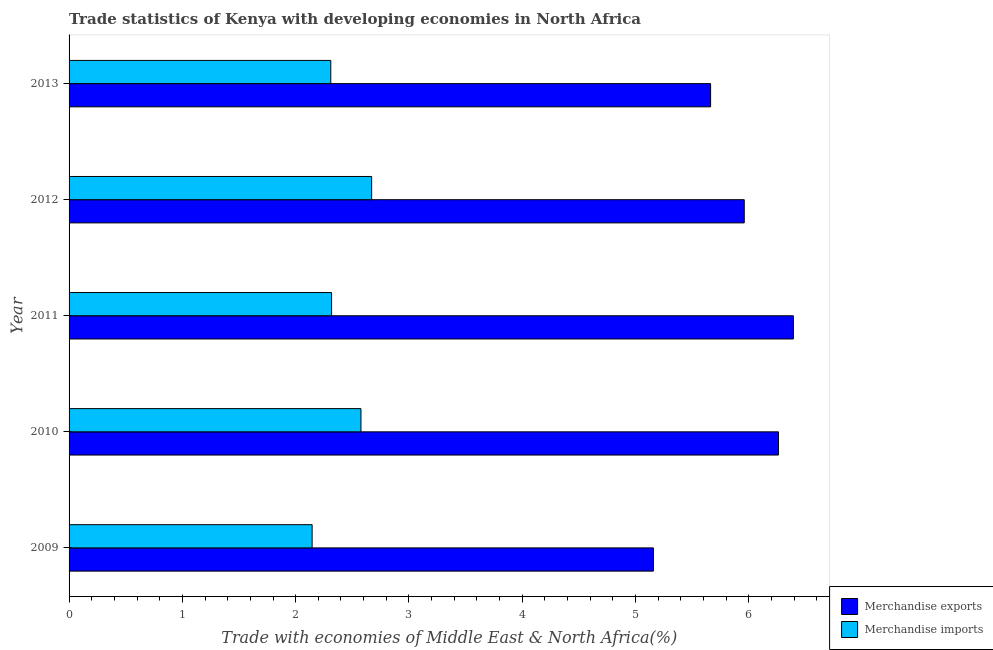How many different coloured bars are there?
Your answer should be compact. 2. Are the number of bars on each tick of the Y-axis equal?
Offer a very short reply. Yes. How many bars are there on the 3rd tick from the top?
Your response must be concise. 2. How many bars are there on the 2nd tick from the bottom?
Your answer should be compact. 2. In how many cases, is the number of bars for a given year not equal to the number of legend labels?
Offer a very short reply. 0. What is the merchandise exports in 2009?
Offer a terse response. 5.16. Across all years, what is the maximum merchandise imports?
Offer a terse response. 2.67. Across all years, what is the minimum merchandise imports?
Provide a succinct answer. 2.15. In which year was the merchandise imports minimum?
Your answer should be compact. 2009. What is the total merchandise exports in the graph?
Your response must be concise. 29.43. What is the difference between the merchandise exports in 2009 and that in 2011?
Your answer should be compact. -1.24. What is the difference between the merchandise imports in 2009 and the merchandise exports in 2010?
Provide a succinct answer. -4.12. What is the average merchandise exports per year?
Give a very brief answer. 5.89. In the year 2009, what is the difference between the merchandise exports and merchandise imports?
Give a very brief answer. 3.01. In how many years, is the merchandise imports greater than 6.2 %?
Your answer should be compact. 0. What is the ratio of the merchandise imports in 2009 to that in 2010?
Make the answer very short. 0.83. Is the merchandise imports in 2009 less than that in 2010?
Offer a very short reply. Yes. Is the difference between the merchandise exports in 2011 and 2012 greater than the difference between the merchandise imports in 2011 and 2012?
Your response must be concise. Yes. What is the difference between the highest and the second highest merchandise exports?
Ensure brevity in your answer.  0.13. What is the difference between the highest and the lowest merchandise imports?
Offer a very short reply. 0.53. In how many years, is the merchandise imports greater than the average merchandise imports taken over all years?
Your answer should be compact. 2. What does the 1st bar from the bottom in 2012 represents?
Your answer should be very brief. Merchandise exports. How many bars are there?
Provide a succinct answer. 10. Are all the bars in the graph horizontal?
Your answer should be very brief. Yes. How many years are there in the graph?
Your answer should be compact. 5. What is the difference between two consecutive major ticks on the X-axis?
Keep it short and to the point. 1. Are the values on the major ticks of X-axis written in scientific E-notation?
Offer a very short reply. No. Does the graph contain any zero values?
Offer a very short reply. No. Where does the legend appear in the graph?
Your response must be concise. Bottom right. How many legend labels are there?
Your response must be concise. 2. What is the title of the graph?
Offer a terse response. Trade statistics of Kenya with developing economies in North Africa. What is the label or title of the X-axis?
Provide a succinct answer. Trade with economies of Middle East & North Africa(%). What is the label or title of the Y-axis?
Your answer should be compact. Year. What is the Trade with economies of Middle East & North Africa(%) in Merchandise exports in 2009?
Ensure brevity in your answer.  5.16. What is the Trade with economies of Middle East & North Africa(%) of Merchandise imports in 2009?
Your answer should be very brief. 2.15. What is the Trade with economies of Middle East & North Africa(%) in Merchandise exports in 2010?
Ensure brevity in your answer.  6.26. What is the Trade with economies of Middle East & North Africa(%) of Merchandise imports in 2010?
Offer a terse response. 2.58. What is the Trade with economies of Middle East & North Africa(%) in Merchandise exports in 2011?
Your response must be concise. 6.39. What is the Trade with economies of Middle East & North Africa(%) in Merchandise imports in 2011?
Offer a very short reply. 2.32. What is the Trade with economies of Middle East & North Africa(%) in Merchandise exports in 2012?
Make the answer very short. 5.96. What is the Trade with economies of Middle East & North Africa(%) of Merchandise imports in 2012?
Your response must be concise. 2.67. What is the Trade with economies of Middle East & North Africa(%) in Merchandise exports in 2013?
Ensure brevity in your answer.  5.66. What is the Trade with economies of Middle East & North Africa(%) in Merchandise imports in 2013?
Your answer should be very brief. 2.31. Across all years, what is the maximum Trade with economies of Middle East & North Africa(%) of Merchandise exports?
Provide a succinct answer. 6.39. Across all years, what is the maximum Trade with economies of Middle East & North Africa(%) of Merchandise imports?
Your answer should be compact. 2.67. Across all years, what is the minimum Trade with economies of Middle East & North Africa(%) of Merchandise exports?
Provide a succinct answer. 5.16. Across all years, what is the minimum Trade with economies of Middle East & North Africa(%) of Merchandise imports?
Your answer should be very brief. 2.15. What is the total Trade with economies of Middle East & North Africa(%) of Merchandise exports in the graph?
Keep it short and to the point. 29.43. What is the total Trade with economies of Middle East & North Africa(%) of Merchandise imports in the graph?
Your response must be concise. 12.02. What is the difference between the Trade with economies of Middle East & North Africa(%) in Merchandise exports in 2009 and that in 2010?
Make the answer very short. -1.1. What is the difference between the Trade with economies of Middle East & North Africa(%) in Merchandise imports in 2009 and that in 2010?
Offer a terse response. -0.43. What is the difference between the Trade with economies of Middle East & North Africa(%) of Merchandise exports in 2009 and that in 2011?
Provide a succinct answer. -1.24. What is the difference between the Trade with economies of Middle East & North Africa(%) in Merchandise imports in 2009 and that in 2011?
Offer a very short reply. -0.17. What is the difference between the Trade with economies of Middle East & North Africa(%) of Merchandise exports in 2009 and that in 2012?
Provide a succinct answer. -0.8. What is the difference between the Trade with economies of Middle East & North Africa(%) of Merchandise imports in 2009 and that in 2012?
Provide a short and direct response. -0.53. What is the difference between the Trade with economies of Middle East & North Africa(%) in Merchandise exports in 2009 and that in 2013?
Provide a short and direct response. -0.5. What is the difference between the Trade with economies of Middle East & North Africa(%) of Merchandise imports in 2009 and that in 2013?
Provide a short and direct response. -0.16. What is the difference between the Trade with economies of Middle East & North Africa(%) in Merchandise exports in 2010 and that in 2011?
Provide a succinct answer. -0.13. What is the difference between the Trade with economies of Middle East & North Africa(%) in Merchandise imports in 2010 and that in 2011?
Give a very brief answer. 0.26. What is the difference between the Trade with economies of Middle East & North Africa(%) in Merchandise exports in 2010 and that in 2012?
Your answer should be compact. 0.3. What is the difference between the Trade with economies of Middle East & North Africa(%) of Merchandise imports in 2010 and that in 2012?
Offer a terse response. -0.09. What is the difference between the Trade with economies of Middle East & North Africa(%) of Merchandise exports in 2010 and that in 2013?
Provide a short and direct response. 0.6. What is the difference between the Trade with economies of Middle East & North Africa(%) of Merchandise imports in 2010 and that in 2013?
Provide a succinct answer. 0.27. What is the difference between the Trade with economies of Middle East & North Africa(%) of Merchandise exports in 2011 and that in 2012?
Your answer should be very brief. 0.43. What is the difference between the Trade with economies of Middle East & North Africa(%) in Merchandise imports in 2011 and that in 2012?
Your answer should be compact. -0.35. What is the difference between the Trade with economies of Middle East & North Africa(%) in Merchandise exports in 2011 and that in 2013?
Give a very brief answer. 0.73. What is the difference between the Trade with economies of Middle East & North Africa(%) of Merchandise imports in 2011 and that in 2013?
Offer a terse response. 0.01. What is the difference between the Trade with economies of Middle East & North Africa(%) of Merchandise exports in 2012 and that in 2013?
Ensure brevity in your answer.  0.3. What is the difference between the Trade with economies of Middle East & North Africa(%) of Merchandise imports in 2012 and that in 2013?
Provide a succinct answer. 0.36. What is the difference between the Trade with economies of Middle East & North Africa(%) of Merchandise exports in 2009 and the Trade with economies of Middle East & North Africa(%) of Merchandise imports in 2010?
Offer a terse response. 2.58. What is the difference between the Trade with economies of Middle East & North Africa(%) in Merchandise exports in 2009 and the Trade with economies of Middle East & North Africa(%) in Merchandise imports in 2011?
Your answer should be compact. 2.84. What is the difference between the Trade with economies of Middle East & North Africa(%) of Merchandise exports in 2009 and the Trade with economies of Middle East & North Africa(%) of Merchandise imports in 2012?
Keep it short and to the point. 2.49. What is the difference between the Trade with economies of Middle East & North Africa(%) in Merchandise exports in 2009 and the Trade with economies of Middle East & North Africa(%) in Merchandise imports in 2013?
Keep it short and to the point. 2.85. What is the difference between the Trade with economies of Middle East & North Africa(%) of Merchandise exports in 2010 and the Trade with economies of Middle East & North Africa(%) of Merchandise imports in 2011?
Offer a terse response. 3.94. What is the difference between the Trade with economies of Middle East & North Africa(%) in Merchandise exports in 2010 and the Trade with economies of Middle East & North Africa(%) in Merchandise imports in 2012?
Your answer should be very brief. 3.59. What is the difference between the Trade with economies of Middle East & North Africa(%) of Merchandise exports in 2010 and the Trade with economies of Middle East & North Africa(%) of Merchandise imports in 2013?
Offer a terse response. 3.95. What is the difference between the Trade with economies of Middle East & North Africa(%) of Merchandise exports in 2011 and the Trade with economies of Middle East & North Africa(%) of Merchandise imports in 2012?
Ensure brevity in your answer.  3.72. What is the difference between the Trade with economies of Middle East & North Africa(%) of Merchandise exports in 2011 and the Trade with economies of Middle East & North Africa(%) of Merchandise imports in 2013?
Keep it short and to the point. 4.08. What is the difference between the Trade with economies of Middle East & North Africa(%) of Merchandise exports in 2012 and the Trade with economies of Middle East & North Africa(%) of Merchandise imports in 2013?
Ensure brevity in your answer.  3.65. What is the average Trade with economies of Middle East & North Africa(%) of Merchandise exports per year?
Your response must be concise. 5.89. What is the average Trade with economies of Middle East & North Africa(%) of Merchandise imports per year?
Provide a succinct answer. 2.4. In the year 2009, what is the difference between the Trade with economies of Middle East & North Africa(%) of Merchandise exports and Trade with economies of Middle East & North Africa(%) of Merchandise imports?
Provide a short and direct response. 3.01. In the year 2010, what is the difference between the Trade with economies of Middle East & North Africa(%) of Merchandise exports and Trade with economies of Middle East & North Africa(%) of Merchandise imports?
Provide a short and direct response. 3.69. In the year 2011, what is the difference between the Trade with economies of Middle East & North Africa(%) in Merchandise exports and Trade with economies of Middle East & North Africa(%) in Merchandise imports?
Ensure brevity in your answer.  4.08. In the year 2012, what is the difference between the Trade with economies of Middle East & North Africa(%) in Merchandise exports and Trade with economies of Middle East & North Africa(%) in Merchandise imports?
Your answer should be compact. 3.29. In the year 2013, what is the difference between the Trade with economies of Middle East & North Africa(%) of Merchandise exports and Trade with economies of Middle East & North Africa(%) of Merchandise imports?
Make the answer very short. 3.35. What is the ratio of the Trade with economies of Middle East & North Africa(%) of Merchandise exports in 2009 to that in 2010?
Offer a terse response. 0.82. What is the ratio of the Trade with economies of Middle East & North Africa(%) in Merchandise imports in 2009 to that in 2010?
Your answer should be very brief. 0.83. What is the ratio of the Trade with economies of Middle East & North Africa(%) in Merchandise exports in 2009 to that in 2011?
Offer a very short reply. 0.81. What is the ratio of the Trade with economies of Middle East & North Africa(%) of Merchandise imports in 2009 to that in 2011?
Your response must be concise. 0.93. What is the ratio of the Trade with economies of Middle East & North Africa(%) in Merchandise exports in 2009 to that in 2012?
Your response must be concise. 0.87. What is the ratio of the Trade with economies of Middle East & North Africa(%) in Merchandise imports in 2009 to that in 2012?
Offer a very short reply. 0.8. What is the ratio of the Trade with economies of Middle East & North Africa(%) of Merchandise exports in 2009 to that in 2013?
Your answer should be compact. 0.91. What is the ratio of the Trade with economies of Middle East & North Africa(%) of Merchandise imports in 2009 to that in 2013?
Provide a short and direct response. 0.93. What is the ratio of the Trade with economies of Middle East & North Africa(%) of Merchandise exports in 2010 to that in 2011?
Your answer should be very brief. 0.98. What is the ratio of the Trade with economies of Middle East & North Africa(%) in Merchandise imports in 2010 to that in 2011?
Provide a short and direct response. 1.11. What is the ratio of the Trade with economies of Middle East & North Africa(%) in Merchandise exports in 2010 to that in 2012?
Give a very brief answer. 1.05. What is the ratio of the Trade with economies of Middle East & North Africa(%) of Merchandise imports in 2010 to that in 2012?
Give a very brief answer. 0.96. What is the ratio of the Trade with economies of Middle East & North Africa(%) of Merchandise exports in 2010 to that in 2013?
Your answer should be very brief. 1.11. What is the ratio of the Trade with economies of Middle East & North Africa(%) of Merchandise imports in 2010 to that in 2013?
Provide a short and direct response. 1.12. What is the ratio of the Trade with economies of Middle East & North Africa(%) of Merchandise exports in 2011 to that in 2012?
Make the answer very short. 1.07. What is the ratio of the Trade with economies of Middle East & North Africa(%) in Merchandise imports in 2011 to that in 2012?
Ensure brevity in your answer.  0.87. What is the ratio of the Trade with economies of Middle East & North Africa(%) of Merchandise exports in 2011 to that in 2013?
Provide a succinct answer. 1.13. What is the ratio of the Trade with economies of Middle East & North Africa(%) of Merchandise imports in 2011 to that in 2013?
Provide a short and direct response. 1. What is the ratio of the Trade with economies of Middle East & North Africa(%) of Merchandise exports in 2012 to that in 2013?
Provide a short and direct response. 1.05. What is the ratio of the Trade with economies of Middle East & North Africa(%) of Merchandise imports in 2012 to that in 2013?
Provide a short and direct response. 1.16. What is the difference between the highest and the second highest Trade with economies of Middle East & North Africa(%) in Merchandise exports?
Offer a terse response. 0.13. What is the difference between the highest and the second highest Trade with economies of Middle East & North Africa(%) of Merchandise imports?
Give a very brief answer. 0.09. What is the difference between the highest and the lowest Trade with economies of Middle East & North Africa(%) of Merchandise exports?
Provide a short and direct response. 1.24. What is the difference between the highest and the lowest Trade with economies of Middle East & North Africa(%) in Merchandise imports?
Provide a short and direct response. 0.53. 